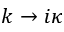<formula> <loc_0><loc_0><loc_500><loc_500>k \to i \kappa</formula> 